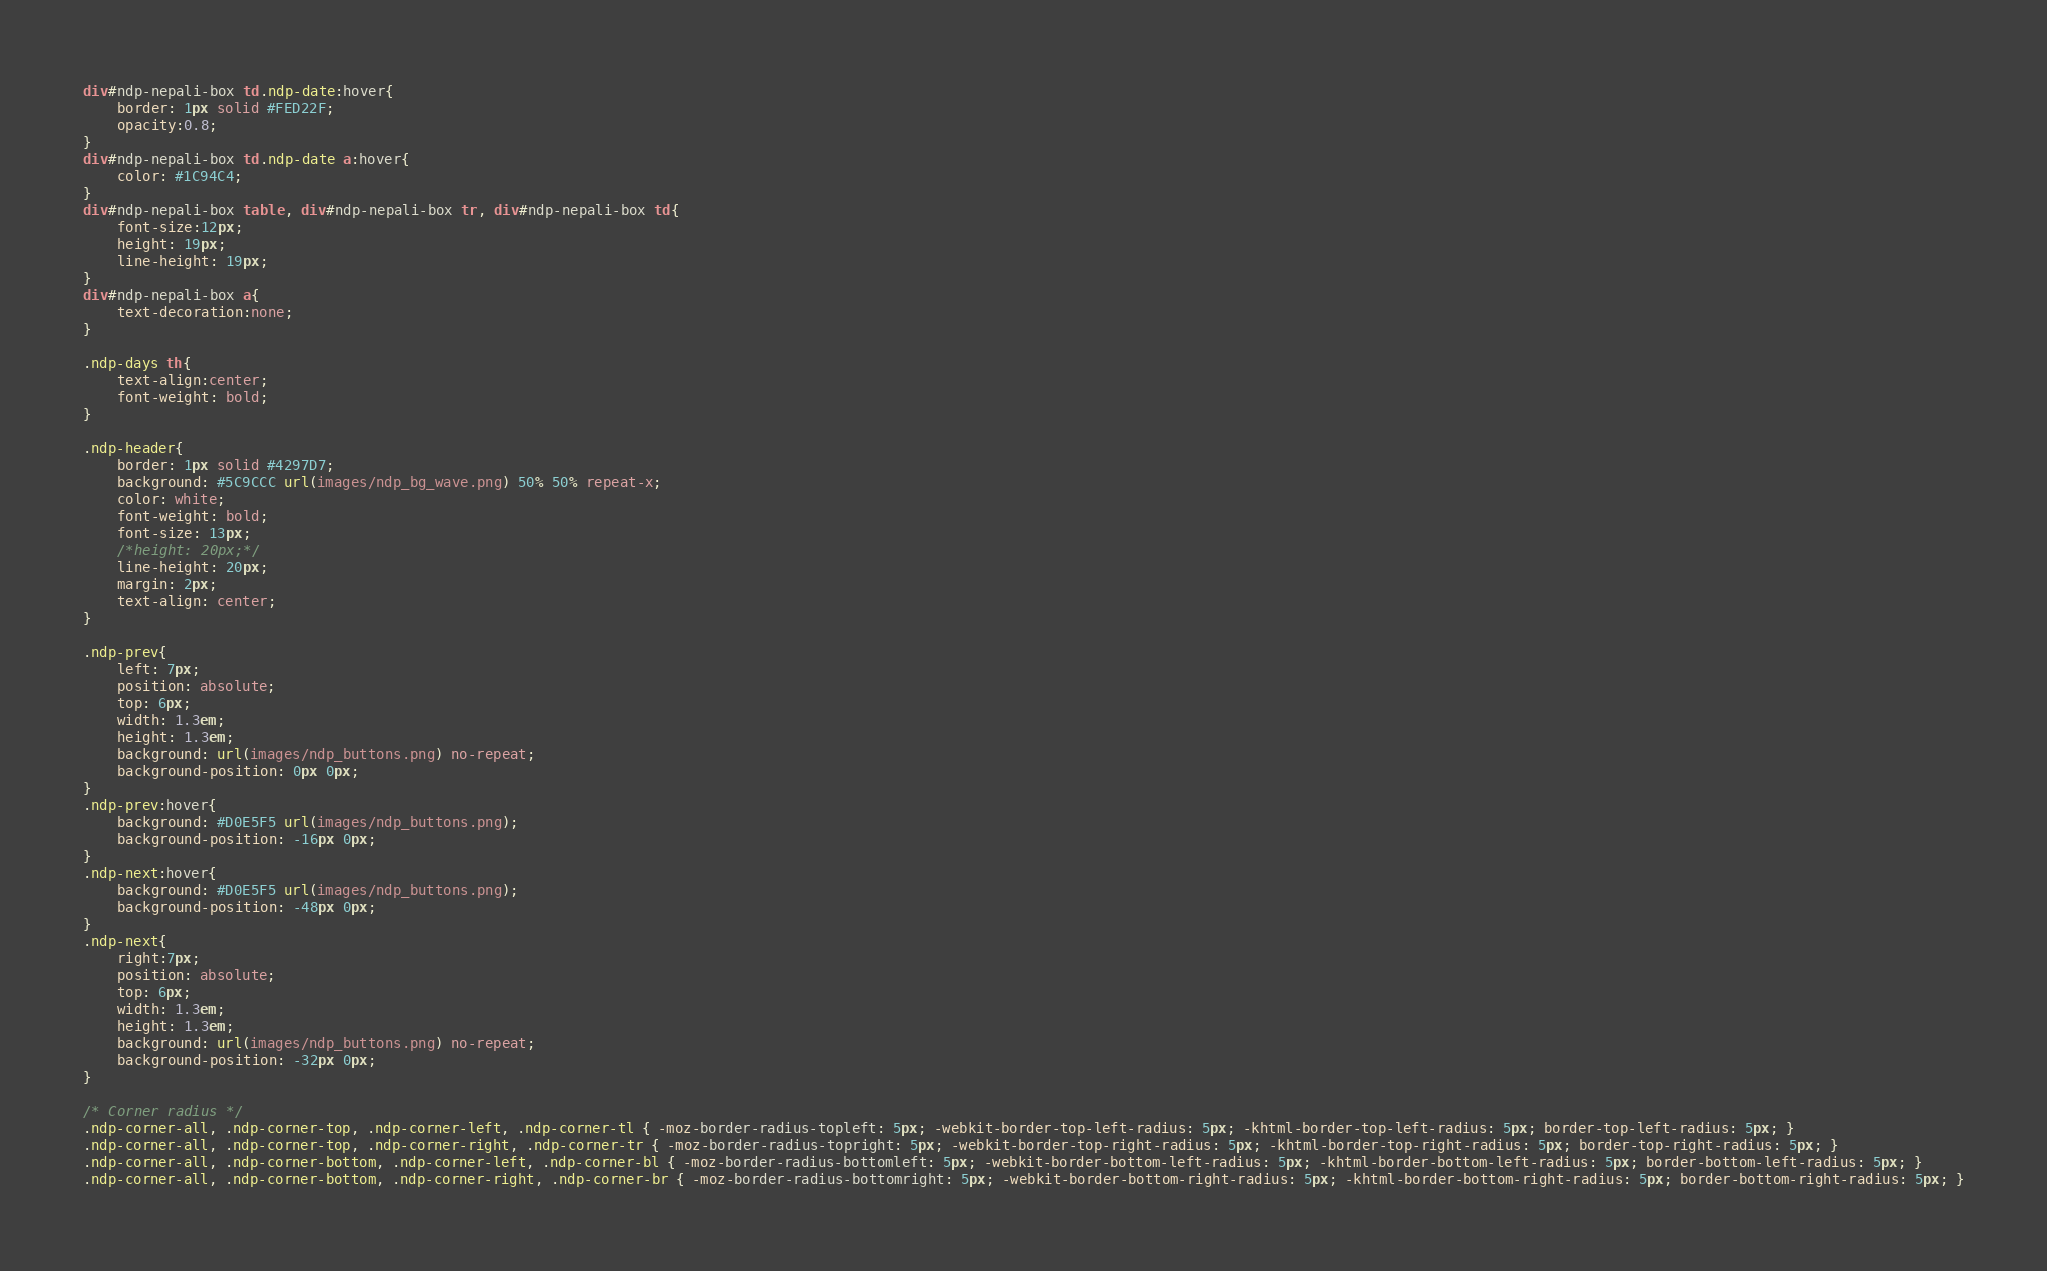Convert code to text. <code><loc_0><loc_0><loc_500><loc_500><_CSS_>div#ndp-nepali-box td.ndp-date:hover{
	border: 1px solid #FED22F; 
	opacity:0.8;
}
div#ndp-nepali-box td.ndp-date a:hover{
	color: #1C94C4;
}
div#ndp-nepali-box table, div#ndp-nepali-box tr, div#ndp-nepali-box td{ 
	font-size:12px;
	height: 19px;
	line-height: 19px;
}
div#ndp-nepali-box a{
	text-decoration:none;
}

.ndp-days th{
	text-align:center;
	font-weight: bold;
}

.ndp-header{
	border: 1px solid #4297D7;
	background: #5C9CCC url(images/ndp_bg_wave.png) 50% 50% repeat-x;
	color: white;
	font-weight: bold;
	font-size: 13px;
	/*height: 20px;*/
	line-height: 20px;
	margin: 2px;
	text-align: center;
}

.ndp-prev{
	left: 7px;
	position: absolute;
	top: 6px;
	width: 1.3em;
	height: 1.3em;
	background: url(images/ndp_buttons.png) no-repeat;
    background-position: 0px 0px;
}
.ndp-prev:hover{
	background: #D0E5F5 url(images/ndp_buttons.png);
	background-position: -16px 0px;
}
.ndp-next:hover{
	background: #D0E5F5 url(images/ndp_buttons.png);
	background-position: -48px 0px;
}
.ndp-next{
	right:7px;
	position: absolute;
	top: 6px;
	width: 1.3em;
	height: 1.3em;
	background: url(images/ndp_buttons.png) no-repeat;
    background-position: -32px 0px;
}

/* Corner radius */
.ndp-corner-all, .ndp-corner-top, .ndp-corner-left, .ndp-corner-tl { -moz-border-radius-topleft: 5px; -webkit-border-top-left-radius: 5px; -khtml-border-top-left-radius: 5px; border-top-left-radius: 5px; }
.ndp-corner-all, .ndp-corner-top, .ndp-corner-right, .ndp-corner-tr { -moz-border-radius-topright: 5px; -webkit-border-top-right-radius: 5px; -khtml-border-top-right-radius: 5px; border-top-right-radius: 5px; }
.ndp-corner-all, .ndp-corner-bottom, .ndp-corner-left, .ndp-corner-bl { -moz-border-radius-bottomleft: 5px; -webkit-border-bottom-left-radius: 5px; -khtml-border-bottom-left-radius: 5px; border-bottom-left-radius: 5px; }
.ndp-corner-all, .ndp-corner-bottom, .ndp-corner-right, .ndp-corner-br { -moz-border-radius-bottomright: 5px; -webkit-border-bottom-right-radius: 5px; -khtml-border-bottom-right-radius: 5px; border-bottom-right-radius: 5px; }</code> 